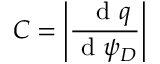Convert formula to latex. <formula><loc_0><loc_0><loc_500><loc_500>C = \left | \frac { \ d q } { d \psi _ { D } } \right |</formula> 